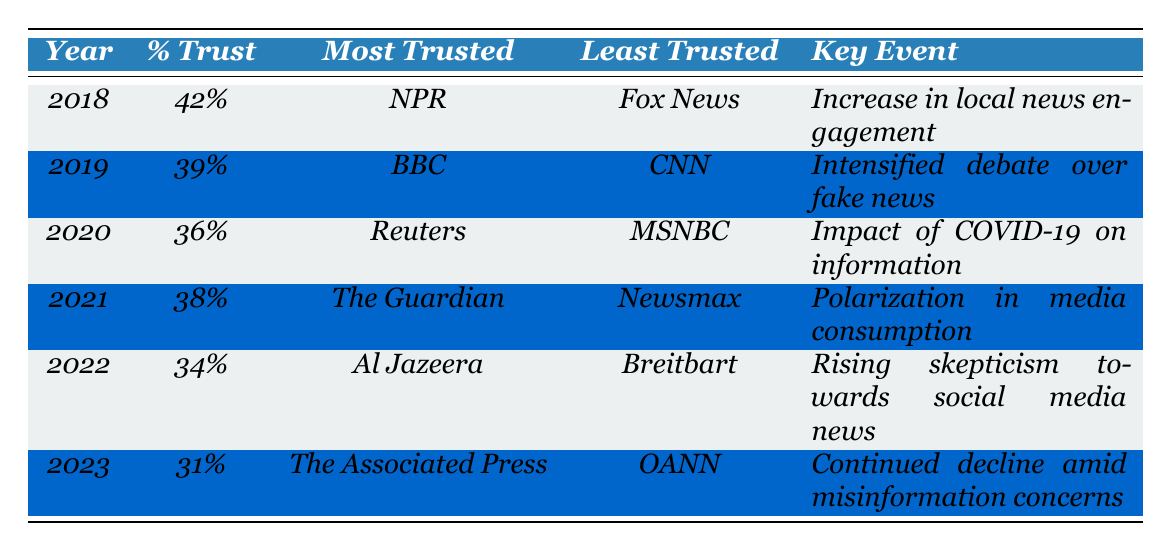What was the percentage of trust in media in 2020? The table shows the percentage of trust in media for the year 2020 is 36%.
Answer: 36% Which news source was least trusted in 2021? According to the table, the least trusted source in 2021 was Newsmax.
Answer: Newsmax What is the key event associated with the year 2022? The table indicates that the key event for 2022 was the rising skepticism towards social media news.
Answer: Rising skepticism towards social media news Which year experienced the highest percentage of trust in media? The table shows that 2018 had the highest percentage of trust at 42%.
Answer: 2018 What was the percentage difference in trust between 2022 and 2023? The percentage of trust in 2022 was 34% and in 2023 it was 31%. The difference is 34 - 31 = 3%.
Answer: 3% Is BBC the most trusted source in 2018? The table states that NPR was the most trusted source in 2018, so the answer is no.
Answer: No In which year did the percentage of trust drop below 35%? Looking at the table, the percentages dropped below 35% in both 2022 (34%) and 2023 (31%).
Answer: 2022 and 2023 Which two news sources were both the most trusted in their respective years? The most trusted sources are NPR in 2018 and The Associated Press in 2023. In total, there are 6 unique sources listed; the most trusted have changed every year. Both sources are distinct and not repeated.
Answer: NPR and The Associated Press If the trend continues, can we expect the percentage of trust in 2024 to be lower than in 2023? The data shows a declining trend in trust from previous years; thus, it would be reasonable to conclude that if this trend continues, the percentage of trust in 2024 could be lower than 31%.
Answer: Yes What was the most trusted news source in 2019 and what key event occurred in that year? According to the table, the most trusted source in 2019 was BBC, and the key event was the intensified debate over fake news.
Answer: BBC; intensified debate over fake news 